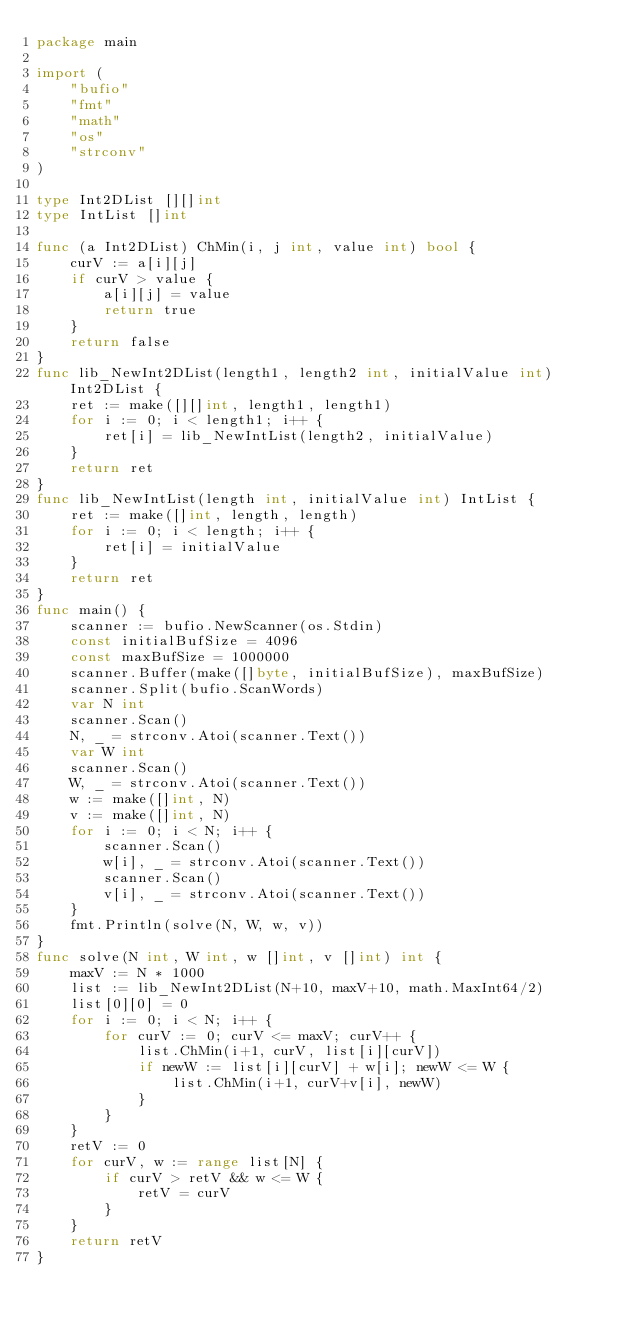<code> <loc_0><loc_0><loc_500><loc_500><_Go_>package main

import (
	"bufio"
	"fmt"
	"math"
	"os"
	"strconv"
)

type Int2DList [][]int
type IntList []int

func (a Int2DList) ChMin(i, j int, value int) bool {
	curV := a[i][j]
	if curV > value {
		a[i][j] = value
		return true
	}
	return false
}
func lib_NewInt2DList(length1, length2 int, initialValue int) Int2DList {
	ret := make([][]int, length1, length1)
	for i := 0; i < length1; i++ {
		ret[i] = lib_NewIntList(length2, initialValue)
	}
	return ret
}
func lib_NewIntList(length int, initialValue int) IntList {
	ret := make([]int, length, length)
	for i := 0; i < length; i++ {
		ret[i] = initialValue
	}
	return ret
}
func main() {
	scanner := bufio.NewScanner(os.Stdin)
	const initialBufSize = 4096
	const maxBufSize = 1000000
	scanner.Buffer(make([]byte, initialBufSize), maxBufSize)
	scanner.Split(bufio.ScanWords)
	var N int
	scanner.Scan()
	N, _ = strconv.Atoi(scanner.Text())
	var W int
	scanner.Scan()
	W, _ = strconv.Atoi(scanner.Text())
	w := make([]int, N)
	v := make([]int, N)
	for i := 0; i < N; i++ {
		scanner.Scan()
		w[i], _ = strconv.Atoi(scanner.Text())
		scanner.Scan()
		v[i], _ = strconv.Atoi(scanner.Text())
	}
	fmt.Println(solve(N, W, w, v))
}
func solve(N int, W int, w []int, v []int) int {
	maxV := N * 1000
	list := lib_NewInt2DList(N+10, maxV+10, math.MaxInt64/2)
	list[0][0] = 0
	for i := 0; i < N; i++ {
		for curV := 0; curV <= maxV; curV++ {
			list.ChMin(i+1, curV, list[i][curV])
			if newW := list[i][curV] + w[i]; newW <= W {
				list.ChMin(i+1, curV+v[i], newW)
			}
		}
	}
	retV := 0
	for curV, w := range list[N] {
		if curV > retV && w <= W {
			retV = curV
		}
	}
	return retV
}
</code> 